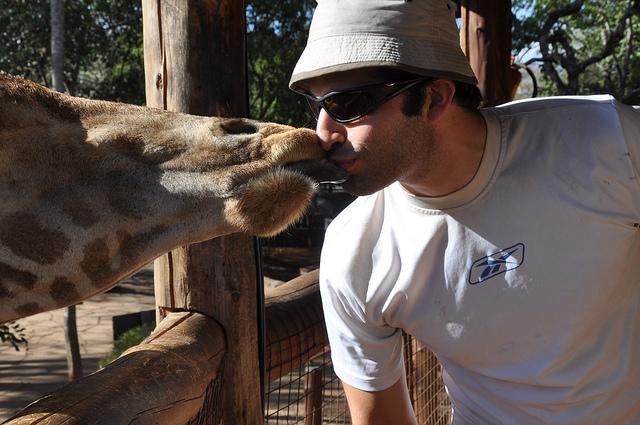Is he eating a sandwich?
Answer briefly. No. What is the man doing to the giraffe?
Be succinct. Kissing. Is this at the zoo?
Be succinct. Yes. Is this a wild animal?
Be succinct. No. 